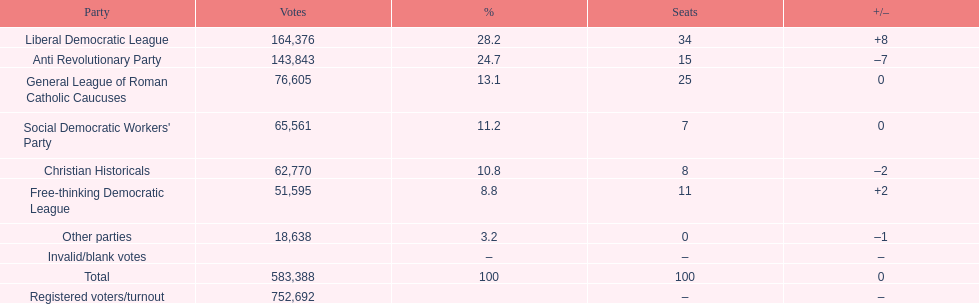How many more votes did the liberal democratic league win over the free-thinking democratic league? 112,781. 